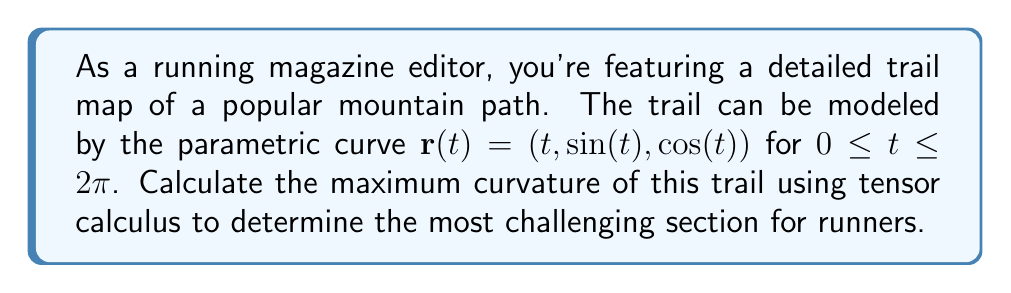Can you answer this question? To calculate the curvature of the trail using tensor calculus, we'll follow these steps:

1) First, we need to calculate the metric tensor $g_{ij}$. For a parametric curve $\mathbf{r}(t) = (x(t), y(t), z(t))$, the metric tensor is given by:

   $$g_{11} = \dot{x}^2 + \dot{y}^2 + \dot{z}^2$$

   where dots represent derivatives with respect to $t$.

2) Calculate the derivatives:
   $$\dot{x} = 1, \quad \dot{y} = \cos(t), \quad \dot{z} = -\sin(t)$$

3) Substitute into the metric tensor:
   $$g_{11} = 1^2 + \cos^2(t) + \sin^2(t) = 2$$

4) The Christoffel symbol of the second kind is given by:
   $$\Gamma^1_{11} = \frac{1}{2g_{11}}\frac{dg_{11}}{dt} = 0$$
   (since $g_{11}$ is constant)

5) The geodesic curvature is given by:
   $$\kappa_g = \frac{|\ddot{\mathbf{r}} + \Gamma^1_{11}\dot{\mathbf{r}}|}{\sqrt{g_{11}}}$$

6) Calculate $\ddot{\mathbf{r}}$:
   $$\ddot{\mathbf{r}} = (0, -\sin(t), -\cos(t))$$

7) Substitute into the curvature formula:
   $$\kappa_g = \frac{\sqrt{0^2 + \sin^2(t) + \cos^2(t)}}{\sqrt{2}} = \frac{1}{\sqrt{2}}$$

8) The curvature is constant along the entire trail, so this is also the maximum curvature.
Answer: $\frac{1}{\sqrt{2}}$ 